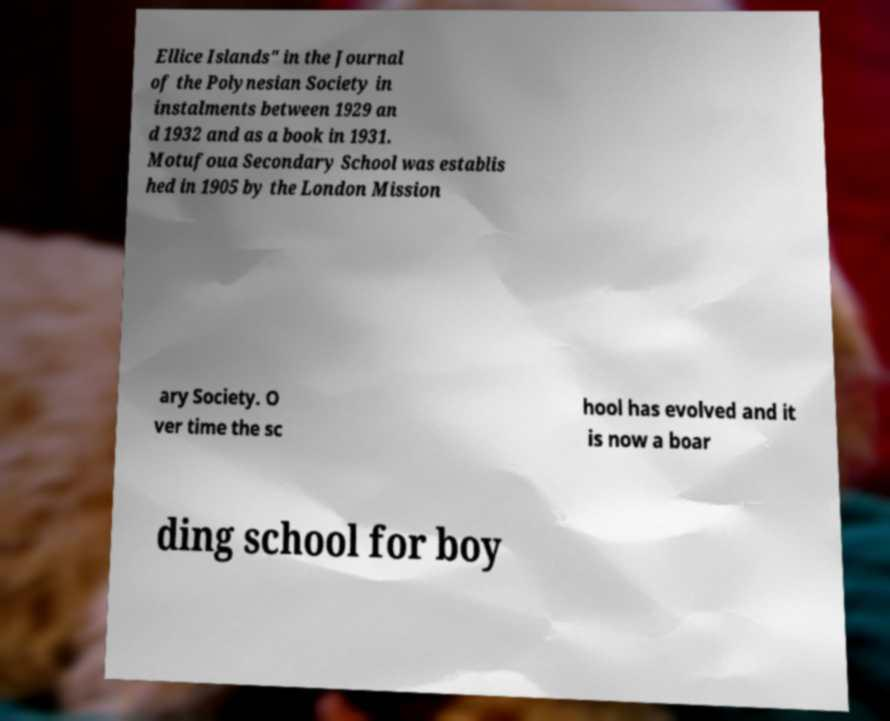What messages or text are displayed in this image? I need them in a readable, typed format. Ellice Islands" in the Journal of the Polynesian Society in instalments between 1929 an d 1932 and as a book in 1931. Motufoua Secondary School was establis hed in 1905 by the London Mission ary Society. O ver time the sc hool has evolved and it is now a boar ding school for boy 